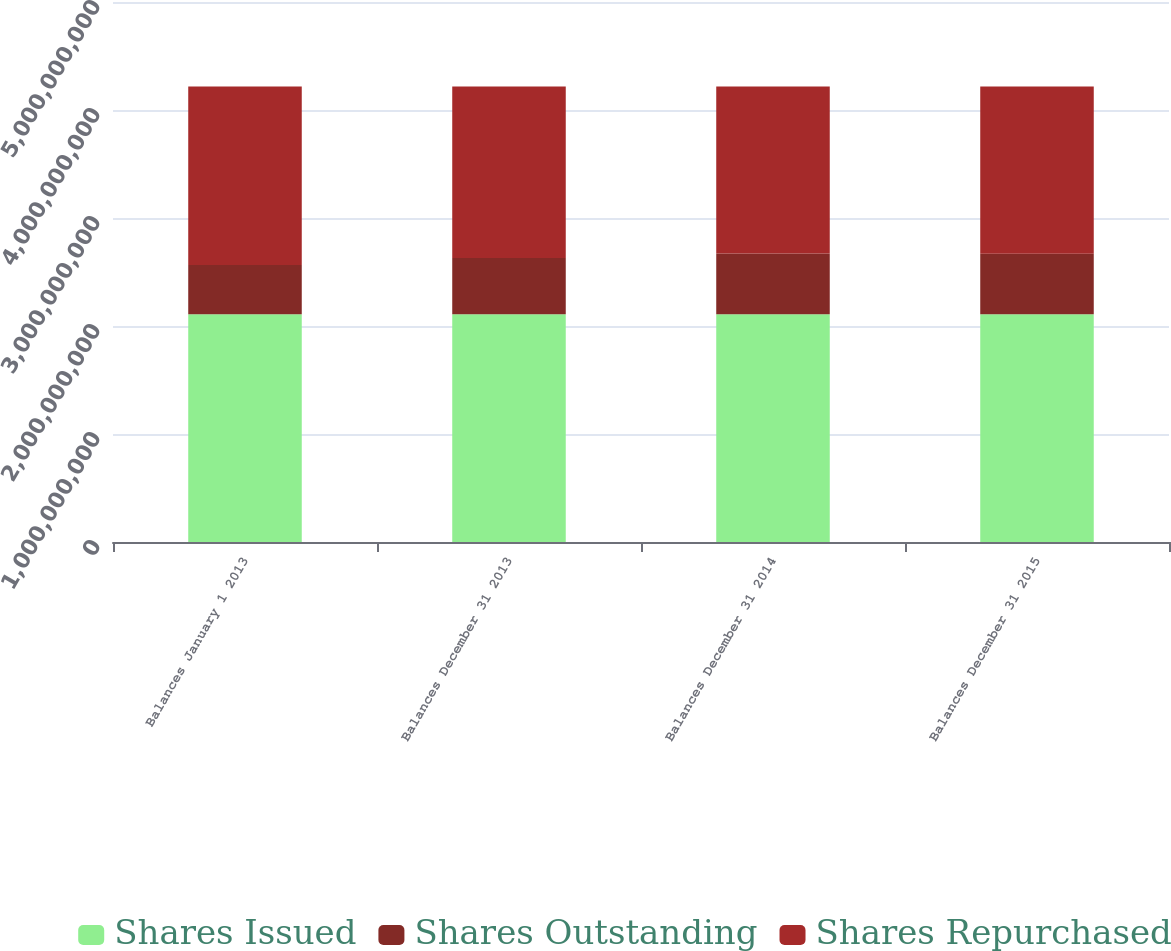Convert chart to OTSL. <chart><loc_0><loc_0><loc_500><loc_500><stacked_bar_chart><ecel><fcel>Balances January 1 2013<fcel>Balances December 31 2013<fcel>Balances December 31 2014<fcel>Balances December 31 2015<nl><fcel>Shares Issued<fcel>2.10932e+09<fcel>2.10932e+09<fcel>2.10932e+09<fcel>2.10932e+09<nl><fcel>Shares Outstanding<fcel>4.55703e+08<fcel>5.20314e+08<fcel>5.62417e+08<fcel>5.59972e+08<nl><fcel>Shares Repurchased<fcel>1.65361e+09<fcel>1.589e+09<fcel>1.5469e+09<fcel>1.54934e+09<nl></chart> 